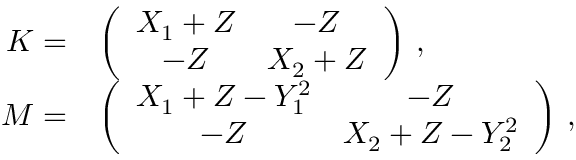<formula> <loc_0><loc_0><loc_500><loc_500>\begin{array} { r l } { K = } & { \left ( \begin{array} { c c } { X _ { 1 } + Z } & { - Z } \\ { - Z } & { X _ { 2 } + Z } \end{array} \right ) \, , } \\ { M = } & { \left ( \begin{array} { c c } { X _ { 1 } + Z - Y _ { 1 } ^ { 2 } } & { - Z } \\ { - Z } & { X _ { 2 } + Z - Y _ { 2 } ^ { 2 } } \end{array} \right ) \, , } \end{array}</formula> 